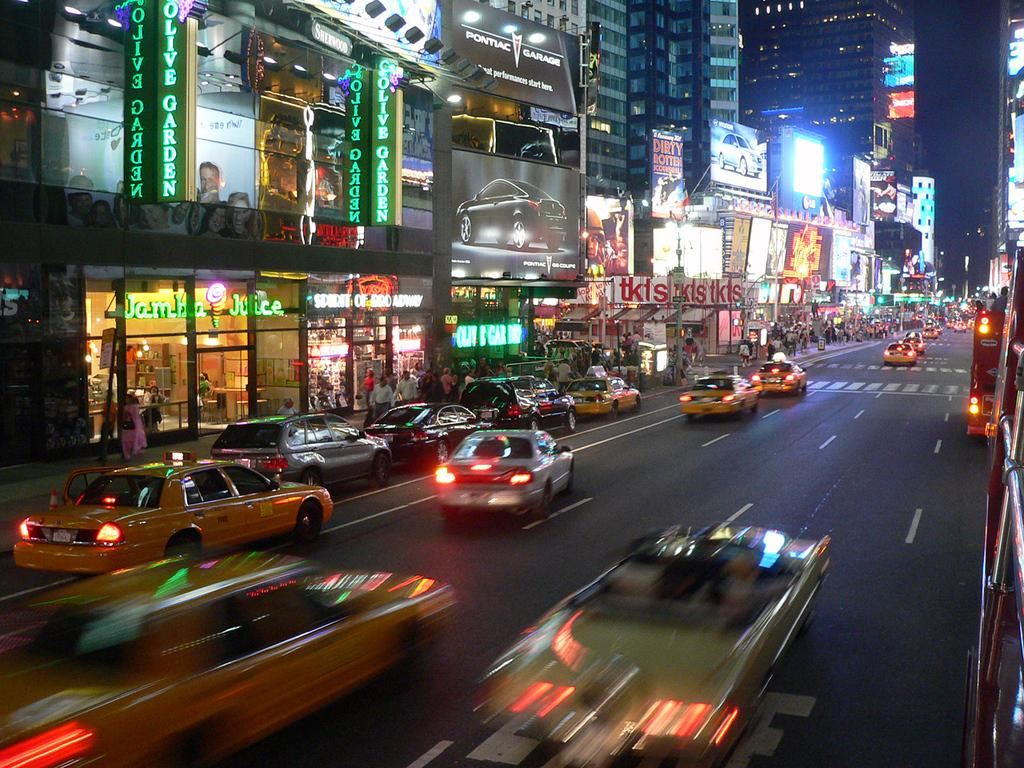<image>
Share a concise interpretation of the image provided. a sign that is outside that has the word garden on it 